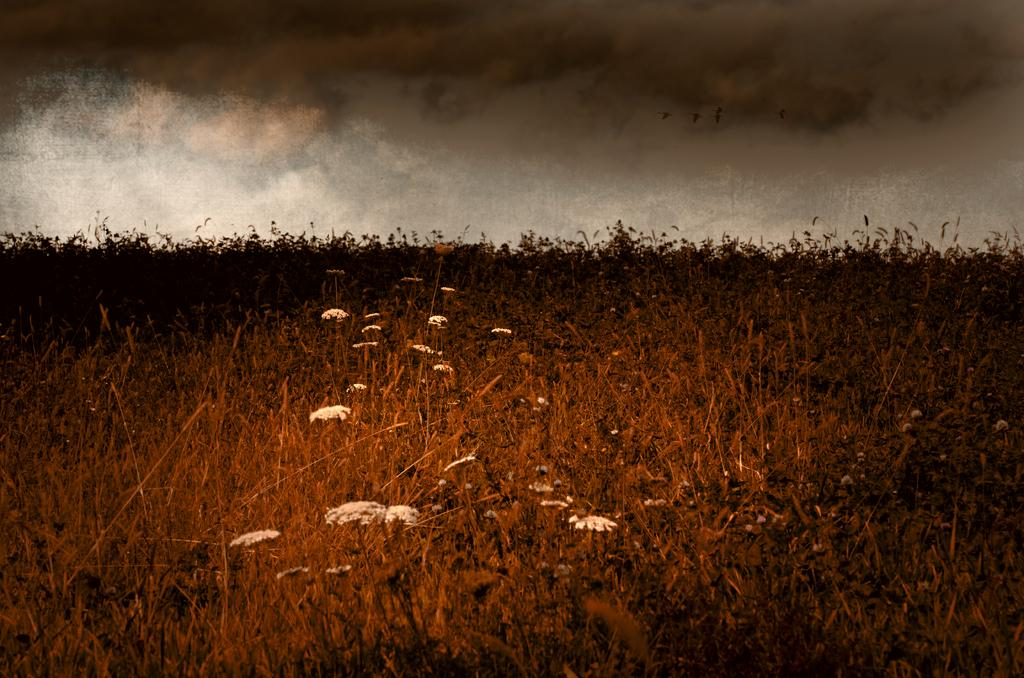What type of living organisms can be seen in the image? Plants and flowers are visible in the image. What else can be seen in the image besides plants and flowers? There are birds in the image. What is visible in the sky in the image? The sky is visible in the image, and there are clouds in the sky. What type of cheese can be seen in the image? There is no cheese present in the image. What color is the silver bird in the image? There is no silver bird present in the image; the birds in the image are not described as being silver. 